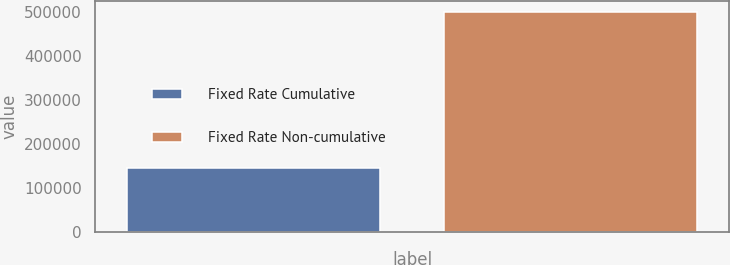<chart> <loc_0><loc_0><loc_500><loc_500><bar_chart><fcel>Fixed Rate Cumulative<fcel>Fixed Rate Non-cumulative<nl><fcel>145535<fcel>500000<nl></chart> 